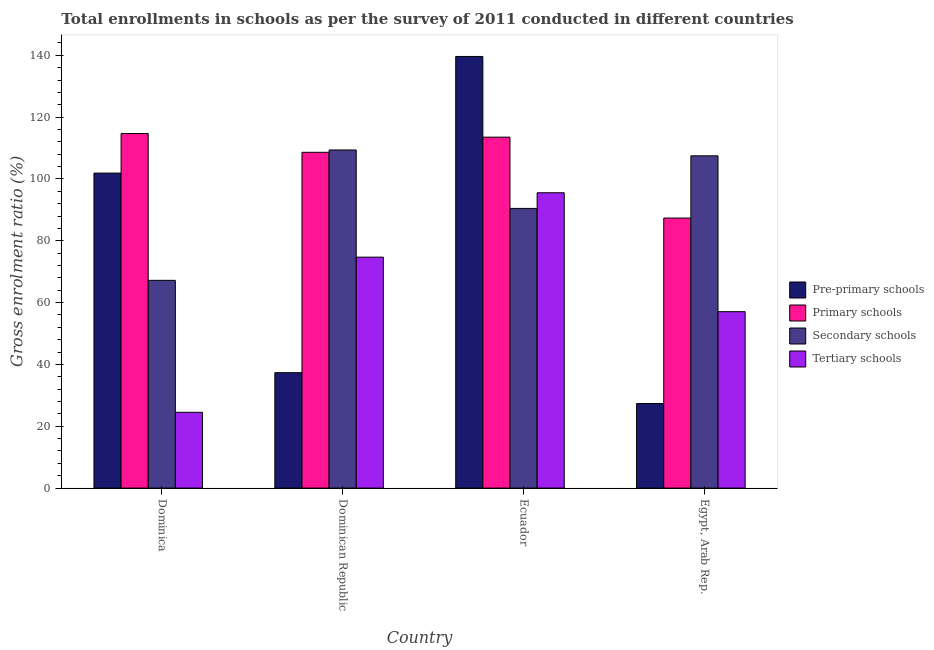How many different coloured bars are there?
Your response must be concise. 4. Are the number of bars on each tick of the X-axis equal?
Offer a terse response. Yes. How many bars are there on the 4th tick from the left?
Your response must be concise. 4. How many bars are there on the 1st tick from the right?
Make the answer very short. 4. What is the label of the 1st group of bars from the left?
Make the answer very short. Dominica. In how many cases, is the number of bars for a given country not equal to the number of legend labels?
Ensure brevity in your answer.  0. What is the gross enrolment ratio in pre-primary schools in Ecuador?
Offer a very short reply. 139.63. Across all countries, what is the maximum gross enrolment ratio in secondary schools?
Provide a short and direct response. 109.37. Across all countries, what is the minimum gross enrolment ratio in primary schools?
Keep it short and to the point. 87.36. In which country was the gross enrolment ratio in secondary schools maximum?
Give a very brief answer. Dominican Republic. In which country was the gross enrolment ratio in tertiary schools minimum?
Offer a terse response. Dominica. What is the total gross enrolment ratio in tertiary schools in the graph?
Your answer should be compact. 251.82. What is the difference between the gross enrolment ratio in tertiary schools in Dominica and that in Dominican Republic?
Your answer should be very brief. -50.19. What is the difference between the gross enrolment ratio in primary schools in Dominica and the gross enrolment ratio in secondary schools in Dominican Republic?
Provide a succinct answer. 5.33. What is the average gross enrolment ratio in pre-primary schools per country?
Offer a terse response. 76.56. What is the difference between the gross enrolment ratio in tertiary schools and gross enrolment ratio in primary schools in Egypt, Arab Rep.?
Provide a short and direct response. -30.29. What is the ratio of the gross enrolment ratio in pre-primary schools in Dominican Republic to that in Ecuador?
Ensure brevity in your answer.  0.27. Is the gross enrolment ratio in primary schools in Dominica less than that in Ecuador?
Your response must be concise. No. What is the difference between the highest and the second highest gross enrolment ratio in secondary schools?
Ensure brevity in your answer.  1.9. What is the difference between the highest and the lowest gross enrolment ratio in secondary schools?
Provide a short and direct response. 42.17. In how many countries, is the gross enrolment ratio in tertiary schools greater than the average gross enrolment ratio in tertiary schools taken over all countries?
Offer a terse response. 2. Is the sum of the gross enrolment ratio in tertiary schools in Dominican Republic and Egypt, Arab Rep. greater than the maximum gross enrolment ratio in pre-primary schools across all countries?
Offer a terse response. No. What does the 3rd bar from the left in Ecuador represents?
Give a very brief answer. Secondary schools. What does the 4th bar from the right in Dominican Republic represents?
Make the answer very short. Pre-primary schools. Are all the bars in the graph horizontal?
Provide a short and direct response. No. What is the difference between two consecutive major ticks on the Y-axis?
Your answer should be compact. 20. Does the graph contain grids?
Keep it short and to the point. No. Where does the legend appear in the graph?
Make the answer very short. Center right. What is the title of the graph?
Offer a very short reply. Total enrollments in schools as per the survey of 2011 conducted in different countries. What is the label or title of the X-axis?
Provide a succinct answer. Country. What is the Gross enrolment ratio (%) of Pre-primary schools in Dominica?
Your response must be concise. 101.9. What is the Gross enrolment ratio (%) of Primary schools in Dominica?
Offer a terse response. 114.7. What is the Gross enrolment ratio (%) in Secondary schools in Dominica?
Ensure brevity in your answer.  67.2. What is the Gross enrolment ratio (%) in Tertiary schools in Dominica?
Provide a short and direct response. 24.52. What is the Gross enrolment ratio (%) in Pre-primary schools in Dominican Republic?
Make the answer very short. 37.33. What is the Gross enrolment ratio (%) in Primary schools in Dominican Republic?
Provide a succinct answer. 108.62. What is the Gross enrolment ratio (%) of Secondary schools in Dominican Republic?
Your answer should be very brief. 109.37. What is the Gross enrolment ratio (%) of Tertiary schools in Dominican Republic?
Provide a succinct answer. 74.71. What is the Gross enrolment ratio (%) of Pre-primary schools in Ecuador?
Offer a terse response. 139.63. What is the Gross enrolment ratio (%) of Primary schools in Ecuador?
Make the answer very short. 113.53. What is the Gross enrolment ratio (%) of Secondary schools in Ecuador?
Your answer should be very brief. 90.47. What is the Gross enrolment ratio (%) of Tertiary schools in Ecuador?
Provide a short and direct response. 95.54. What is the Gross enrolment ratio (%) of Pre-primary schools in Egypt, Arab Rep.?
Your answer should be very brief. 27.36. What is the Gross enrolment ratio (%) of Primary schools in Egypt, Arab Rep.?
Make the answer very short. 87.36. What is the Gross enrolment ratio (%) in Secondary schools in Egypt, Arab Rep.?
Make the answer very short. 107.48. What is the Gross enrolment ratio (%) of Tertiary schools in Egypt, Arab Rep.?
Your response must be concise. 57.06. Across all countries, what is the maximum Gross enrolment ratio (%) in Pre-primary schools?
Offer a very short reply. 139.63. Across all countries, what is the maximum Gross enrolment ratio (%) of Primary schools?
Give a very brief answer. 114.7. Across all countries, what is the maximum Gross enrolment ratio (%) in Secondary schools?
Your answer should be very brief. 109.37. Across all countries, what is the maximum Gross enrolment ratio (%) of Tertiary schools?
Your response must be concise. 95.54. Across all countries, what is the minimum Gross enrolment ratio (%) in Pre-primary schools?
Keep it short and to the point. 27.36. Across all countries, what is the minimum Gross enrolment ratio (%) in Primary schools?
Ensure brevity in your answer.  87.36. Across all countries, what is the minimum Gross enrolment ratio (%) of Secondary schools?
Offer a very short reply. 67.2. Across all countries, what is the minimum Gross enrolment ratio (%) of Tertiary schools?
Make the answer very short. 24.52. What is the total Gross enrolment ratio (%) of Pre-primary schools in the graph?
Offer a terse response. 306.22. What is the total Gross enrolment ratio (%) in Primary schools in the graph?
Keep it short and to the point. 424.21. What is the total Gross enrolment ratio (%) of Secondary schools in the graph?
Ensure brevity in your answer.  374.53. What is the total Gross enrolment ratio (%) of Tertiary schools in the graph?
Offer a very short reply. 251.82. What is the difference between the Gross enrolment ratio (%) of Pre-primary schools in Dominica and that in Dominican Republic?
Ensure brevity in your answer.  64.57. What is the difference between the Gross enrolment ratio (%) of Primary schools in Dominica and that in Dominican Republic?
Your answer should be compact. 6.08. What is the difference between the Gross enrolment ratio (%) in Secondary schools in Dominica and that in Dominican Republic?
Offer a terse response. -42.17. What is the difference between the Gross enrolment ratio (%) in Tertiary schools in Dominica and that in Dominican Republic?
Ensure brevity in your answer.  -50.19. What is the difference between the Gross enrolment ratio (%) in Pre-primary schools in Dominica and that in Ecuador?
Keep it short and to the point. -37.73. What is the difference between the Gross enrolment ratio (%) of Primary schools in Dominica and that in Ecuador?
Keep it short and to the point. 1.18. What is the difference between the Gross enrolment ratio (%) in Secondary schools in Dominica and that in Ecuador?
Provide a succinct answer. -23.27. What is the difference between the Gross enrolment ratio (%) of Tertiary schools in Dominica and that in Ecuador?
Give a very brief answer. -71.02. What is the difference between the Gross enrolment ratio (%) of Pre-primary schools in Dominica and that in Egypt, Arab Rep.?
Give a very brief answer. 74.54. What is the difference between the Gross enrolment ratio (%) of Primary schools in Dominica and that in Egypt, Arab Rep.?
Give a very brief answer. 27.35. What is the difference between the Gross enrolment ratio (%) in Secondary schools in Dominica and that in Egypt, Arab Rep.?
Provide a short and direct response. -40.28. What is the difference between the Gross enrolment ratio (%) of Tertiary schools in Dominica and that in Egypt, Arab Rep.?
Provide a succinct answer. -32.55. What is the difference between the Gross enrolment ratio (%) in Pre-primary schools in Dominican Republic and that in Ecuador?
Your answer should be very brief. -102.29. What is the difference between the Gross enrolment ratio (%) in Primary schools in Dominican Republic and that in Ecuador?
Make the answer very short. -4.91. What is the difference between the Gross enrolment ratio (%) of Secondary schools in Dominican Republic and that in Ecuador?
Keep it short and to the point. 18.9. What is the difference between the Gross enrolment ratio (%) of Tertiary schools in Dominican Republic and that in Ecuador?
Provide a succinct answer. -20.83. What is the difference between the Gross enrolment ratio (%) in Pre-primary schools in Dominican Republic and that in Egypt, Arab Rep.?
Provide a short and direct response. 9.97. What is the difference between the Gross enrolment ratio (%) in Primary schools in Dominican Republic and that in Egypt, Arab Rep.?
Your response must be concise. 21.26. What is the difference between the Gross enrolment ratio (%) in Secondary schools in Dominican Republic and that in Egypt, Arab Rep.?
Your response must be concise. 1.9. What is the difference between the Gross enrolment ratio (%) of Tertiary schools in Dominican Republic and that in Egypt, Arab Rep.?
Keep it short and to the point. 17.64. What is the difference between the Gross enrolment ratio (%) in Pre-primary schools in Ecuador and that in Egypt, Arab Rep.?
Your answer should be compact. 112.26. What is the difference between the Gross enrolment ratio (%) in Primary schools in Ecuador and that in Egypt, Arab Rep.?
Give a very brief answer. 26.17. What is the difference between the Gross enrolment ratio (%) of Secondary schools in Ecuador and that in Egypt, Arab Rep.?
Your response must be concise. -17.01. What is the difference between the Gross enrolment ratio (%) in Tertiary schools in Ecuador and that in Egypt, Arab Rep.?
Make the answer very short. 38.47. What is the difference between the Gross enrolment ratio (%) of Pre-primary schools in Dominica and the Gross enrolment ratio (%) of Primary schools in Dominican Republic?
Your response must be concise. -6.72. What is the difference between the Gross enrolment ratio (%) of Pre-primary schools in Dominica and the Gross enrolment ratio (%) of Secondary schools in Dominican Republic?
Your answer should be compact. -7.47. What is the difference between the Gross enrolment ratio (%) of Pre-primary schools in Dominica and the Gross enrolment ratio (%) of Tertiary schools in Dominican Republic?
Offer a very short reply. 27.19. What is the difference between the Gross enrolment ratio (%) in Primary schools in Dominica and the Gross enrolment ratio (%) in Secondary schools in Dominican Republic?
Offer a terse response. 5.33. What is the difference between the Gross enrolment ratio (%) in Primary schools in Dominica and the Gross enrolment ratio (%) in Tertiary schools in Dominican Republic?
Keep it short and to the point. 40. What is the difference between the Gross enrolment ratio (%) in Secondary schools in Dominica and the Gross enrolment ratio (%) in Tertiary schools in Dominican Republic?
Your answer should be very brief. -7.5. What is the difference between the Gross enrolment ratio (%) in Pre-primary schools in Dominica and the Gross enrolment ratio (%) in Primary schools in Ecuador?
Provide a short and direct response. -11.63. What is the difference between the Gross enrolment ratio (%) of Pre-primary schools in Dominica and the Gross enrolment ratio (%) of Secondary schools in Ecuador?
Your answer should be compact. 11.43. What is the difference between the Gross enrolment ratio (%) in Pre-primary schools in Dominica and the Gross enrolment ratio (%) in Tertiary schools in Ecuador?
Offer a very short reply. 6.36. What is the difference between the Gross enrolment ratio (%) in Primary schools in Dominica and the Gross enrolment ratio (%) in Secondary schools in Ecuador?
Provide a succinct answer. 24.23. What is the difference between the Gross enrolment ratio (%) of Primary schools in Dominica and the Gross enrolment ratio (%) of Tertiary schools in Ecuador?
Keep it short and to the point. 19.17. What is the difference between the Gross enrolment ratio (%) in Secondary schools in Dominica and the Gross enrolment ratio (%) in Tertiary schools in Ecuador?
Ensure brevity in your answer.  -28.33. What is the difference between the Gross enrolment ratio (%) of Pre-primary schools in Dominica and the Gross enrolment ratio (%) of Primary schools in Egypt, Arab Rep.?
Ensure brevity in your answer.  14.54. What is the difference between the Gross enrolment ratio (%) of Pre-primary schools in Dominica and the Gross enrolment ratio (%) of Secondary schools in Egypt, Arab Rep.?
Offer a very short reply. -5.58. What is the difference between the Gross enrolment ratio (%) in Pre-primary schools in Dominica and the Gross enrolment ratio (%) in Tertiary schools in Egypt, Arab Rep.?
Your response must be concise. 44.84. What is the difference between the Gross enrolment ratio (%) of Primary schools in Dominica and the Gross enrolment ratio (%) of Secondary schools in Egypt, Arab Rep.?
Keep it short and to the point. 7.23. What is the difference between the Gross enrolment ratio (%) in Primary schools in Dominica and the Gross enrolment ratio (%) in Tertiary schools in Egypt, Arab Rep.?
Your answer should be very brief. 57.64. What is the difference between the Gross enrolment ratio (%) in Secondary schools in Dominica and the Gross enrolment ratio (%) in Tertiary schools in Egypt, Arab Rep.?
Your answer should be compact. 10.14. What is the difference between the Gross enrolment ratio (%) in Pre-primary schools in Dominican Republic and the Gross enrolment ratio (%) in Primary schools in Ecuador?
Provide a short and direct response. -76.19. What is the difference between the Gross enrolment ratio (%) of Pre-primary schools in Dominican Republic and the Gross enrolment ratio (%) of Secondary schools in Ecuador?
Keep it short and to the point. -53.14. What is the difference between the Gross enrolment ratio (%) in Pre-primary schools in Dominican Republic and the Gross enrolment ratio (%) in Tertiary schools in Ecuador?
Make the answer very short. -58.2. What is the difference between the Gross enrolment ratio (%) in Primary schools in Dominican Republic and the Gross enrolment ratio (%) in Secondary schools in Ecuador?
Provide a succinct answer. 18.15. What is the difference between the Gross enrolment ratio (%) of Primary schools in Dominican Republic and the Gross enrolment ratio (%) of Tertiary schools in Ecuador?
Your response must be concise. 13.08. What is the difference between the Gross enrolment ratio (%) in Secondary schools in Dominican Republic and the Gross enrolment ratio (%) in Tertiary schools in Ecuador?
Offer a very short reply. 13.84. What is the difference between the Gross enrolment ratio (%) of Pre-primary schools in Dominican Republic and the Gross enrolment ratio (%) of Primary schools in Egypt, Arab Rep.?
Make the answer very short. -50.03. What is the difference between the Gross enrolment ratio (%) of Pre-primary schools in Dominican Republic and the Gross enrolment ratio (%) of Secondary schools in Egypt, Arab Rep.?
Give a very brief answer. -70.15. What is the difference between the Gross enrolment ratio (%) in Pre-primary schools in Dominican Republic and the Gross enrolment ratio (%) in Tertiary schools in Egypt, Arab Rep.?
Your response must be concise. -19.73. What is the difference between the Gross enrolment ratio (%) in Primary schools in Dominican Republic and the Gross enrolment ratio (%) in Secondary schools in Egypt, Arab Rep.?
Your response must be concise. 1.14. What is the difference between the Gross enrolment ratio (%) of Primary schools in Dominican Republic and the Gross enrolment ratio (%) of Tertiary schools in Egypt, Arab Rep.?
Your response must be concise. 51.56. What is the difference between the Gross enrolment ratio (%) in Secondary schools in Dominican Republic and the Gross enrolment ratio (%) in Tertiary schools in Egypt, Arab Rep.?
Make the answer very short. 52.31. What is the difference between the Gross enrolment ratio (%) in Pre-primary schools in Ecuador and the Gross enrolment ratio (%) in Primary schools in Egypt, Arab Rep.?
Give a very brief answer. 52.27. What is the difference between the Gross enrolment ratio (%) in Pre-primary schools in Ecuador and the Gross enrolment ratio (%) in Secondary schools in Egypt, Arab Rep.?
Keep it short and to the point. 32.15. What is the difference between the Gross enrolment ratio (%) in Pre-primary schools in Ecuador and the Gross enrolment ratio (%) in Tertiary schools in Egypt, Arab Rep.?
Keep it short and to the point. 82.56. What is the difference between the Gross enrolment ratio (%) in Primary schools in Ecuador and the Gross enrolment ratio (%) in Secondary schools in Egypt, Arab Rep.?
Ensure brevity in your answer.  6.05. What is the difference between the Gross enrolment ratio (%) in Primary schools in Ecuador and the Gross enrolment ratio (%) in Tertiary schools in Egypt, Arab Rep.?
Your response must be concise. 56.46. What is the difference between the Gross enrolment ratio (%) in Secondary schools in Ecuador and the Gross enrolment ratio (%) in Tertiary schools in Egypt, Arab Rep.?
Keep it short and to the point. 33.41. What is the average Gross enrolment ratio (%) in Pre-primary schools per country?
Your answer should be very brief. 76.56. What is the average Gross enrolment ratio (%) of Primary schools per country?
Make the answer very short. 106.05. What is the average Gross enrolment ratio (%) in Secondary schools per country?
Ensure brevity in your answer.  93.63. What is the average Gross enrolment ratio (%) of Tertiary schools per country?
Your answer should be compact. 62.96. What is the difference between the Gross enrolment ratio (%) in Pre-primary schools and Gross enrolment ratio (%) in Primary schools in Dominica?
Keep it short and to the point. -12.8. What is the difference between the Gross enrolment ratio (%) of Pre-primary schools and Gross enrolment ratio (%) of Secondary schools in Dominica?
Your response must be concise. 34.7. What is the difference between the Gross enrolment ratio (%) of Pre-primary schools and Gross enrolment ratio (%) of Tertiary schools in Dominica?
Offer a very short reply. 77.38. What is the difference between the Gross enrolment ratio (%) of Primary schools and Gross enrolment ratio (%) of Secondary schools in Dominica?
Offer a terse response. 47.5. What is the difference between the Gross enrolment ratio (%) in Primary schools and Gross enrolment ratio (%) in Tertiary schools in Dominica?
Your answer should be very brief. 90.19. What is the difference between the Gross enrolment ratio (%) of Secondary schools and Gross enrolment ratio (%) of Tertiary schools in Dominica?
Keep it short and to the point. 42.68. What is the difference between the Gross enrolment ratio (%) of Pre-primary schools and Gross enrolment ratio (%) of Primary schools in Dominican Republic?
Keep it short and to the point. -71.29. What is the difference between the Gross enrolment ratio (%) of Pre-primary schools and Gross enrolment ratio (%) of Secondary schools in Dominican Republic?
Make the answer very short. -72.04. What is the difference between the Gross enrolment ratio (%) of Pre-primary schools and Gross enrolment ratio (%) of Tertiary schools in Dominican Republic?
Offer a terse response. -37.37. What is the difference between the Gross enrolment ratio (%) of Primary schools and Gross enrolment ratio (%) of Secondary schools in Dominican Republic?
Your answer should be very brief. -0.75. What is the difference between the Gross enrolment ratio (%) in Primary schools and Gross enrolment ratio (%) in Tertiary schools in Dominican Republic?
Provide a succinct answer. 33.92. What is the difference between the Gross enrolment ratio (%) of Secondary schools and Gross enrolment ratio (%) of Tertiary schools in Dominican Republic?
Offer a very short reply. 34.67. What is the difference between the Gross enrolment ratio (%) of Pre-primary schools and Gross enrolment ratio (%) of Primary schools in Ecuador?
Offer a very short reply. 26.1. What is the difference between the Gross enrolment ratio (%) of Pre-primary schools and Gross enrolment ratio (%) of Secondary schools in Ecuador?
Your answer should be compact. 49.15. What is the difference between the Gross enrolment ratio (%) in Pre-primary schools and Gross enrolment ratio (%) in Tertiary schools in Ecuador?
Offer a terse response. 44.09. What is the difference between the Gross enrolment ratio (%) of Primary schools and Gross enrolment ratio (%) of Secondary schools in Ecuador?
Your answer should be compact. 23.05. What is the difference between the Gross enrolment ratio (%) of Primary schools and Gross enrolment ratio (%) of Tertiary schools in Ecuador?
Your response must be concise. 17.99. What is the difference between the Gross enrolment ratio (%) of Secondary schools and Gross enrolment ratio (%) of Tertiary schools in Ecuador?
Your response must be concise. -5.07. What is the difference between the Gross enrolment ratio (%) of Pre-primary schools and Gross enrolment ratio (%) of Primary schools in Egypt, Arab Rep.?
Keep it short and to the point. -59.99. What is the difference between the Gross enrolment ratio (%) of Pre-primary schools and Gross enrolment ratio (%) of Secondary schools in Egypt, Arab Rep.?
Keep it short and to the point. -80.12. What is the difference between the Gross enrolment ratio (%) of Pre-primary schools and Gross enrolment ratio (%) of Tertiary schools in Egypt, Arab Rep.?
Offer a terse response. -29.7. What is the difference between the Gross enrolment ratio (%) in Primary schools and Gross enrolment ratio (%) in Secondary schools in Egypt, Arab Rep.?
Provide a succinct answer. -20.12. What is the difference between the Gross enrolment ratio (%) in Primary schools and Gross enrolment ratio (%) in Tertiary schools in Egypt, Arab Rep.?
Provide a succinct answer. 30.29. What is the difference between the Gross enrolment ratio (%) of Secondary schools and Gross enrolment ratio (%) of Tertiary schools in Egypt, Arab Rep.?
Ensure brevity in your answer.  50.41. What is the ratio of the Gross enrolment ratio (%) of Pre-primary schools in Dominica to that in Dominican Republic?
Provide a short and direct response. 2.73. What is the ratio of the Gross enrolment ratio (%) in Primary schools in Dominica to that in Dominican Republic?
Make the answer very short. 1.06. What is the ratio of the Gross enrolment ratio (%) of Secondary schools in Dominica to that in Dominican Republic?
Ensure brevity in your answer.  0.61. What is the ratio of the Gross enrolment ratio (%) of Tertiary schools in Dominica to that in Dominican Republic?
Your answer should be compact. 0.33. What is the ratio of the Gross enrolment ratio (%) of Pre-primary schools in Dominica to that in Ecuador?
Offer a very short reply. 0.73. What is the ratio of the Gross enrolment ratio (%) in Primary schools in Dominica to that in Ecuador?
Provide a succinct answer. 1.01. What is the ratio of the Gross enrolment ratio (%) in Secondary schools in Dominica to that in Ecuador?
Ensure brevity in your answer.  0.74. What is the ratio of the Gross enrolment ratio (%) in Tertiary schools in Dominica to that in Ecuador?
Make the answer very short. 0.26. What is the ratio of the Gross enrolment ratio (%) of Pre-primary schools in Dominica to that in Egypt, Arab Rep.?
Your answer should be compact. 3.72. What is the ratio of the Gross enrolment ratio (%) in Primary schools in Dominica to that in Egypt, Arab Rep.?
Provide a succinct answer. 1.31. What is the ratio of the Gross enrolment ratio (%) in Secondary schools in Dominica to that in Egypt, Arab Rep.?
Your response must be concise. 0.63. What is the ratio of the Gross enrolment ratio (%) of Tertiary schools in Dominica to that in Egypt, Arab Rep.?
Your answer should be compact. 0.43. What is the ratio of the Gross enrolment ratio (%) of Pre-primary schools in Dominican Republic to that in Ecuador?
Ensure brevity in your answer.  0.27. What is the ratio of the Gross enrolment ratio (%) in Primary schools in Dominican Republic to that in Ecuador?
Keep it short and to the point. 0.96. What is the ratio of the Gross enrolment ratio (%) in Secondary schools in Dominican Republic to that in Ecuador?
Provide a short and direct response. 1.21. What is the ratio of the Gross enrolment ratio (%) of Tertiary schools in Dominican Republic to that in Ecuador?
Offer a very short reply. 0.78. What is the ratio of the Gross enrolment ratio (%) in Pre-primary schools in Dominican Republic to that in Egypt, Arab Rep.?
Make the answer very short. 1.36. What is the ratio of the Gross enrolment ratio (%) of Primary schools in Dominican Republic to that in Egypt, Arab Rep.?
Offer a terse response. 1.24. What is the ratio of the Gross enrolment ratio (%) of Secondary schools in Dominican Republic to that in Egypt, Arab Rep.?
Make the answer very short. 1.02. What is the ratio of the Gross enrolment ratio (%) of Tertiary schools in Dominican Republic to that in Egypt, Arab Rep.?
Provide a succinct answer. 1.31. What is the ratio of the Gross enrolment ratio (%) of Pre-primary schools in Ecuador to that in Egypt, Arab Rep.?
Make the answer very short. 5.1. What is the ratio of the Gross enrolment ratio (%) in Primary schools in Ecuador to that in Egypt, Arab Rep.?
Ensure brevity in your answer.  1.3. What is the ratio of the Gross enrolment ratio (%) in Secondary schools in Ecuador to that in Egypt, Arab Rep.?
Provide a succinct answer. 0.84. What is the ratio of the Gross enrolment ratio (%) of Tertiary schools in Ecuador to that in Egypt, Arab Rep.?
Provide a succinct answer. 1.67. What is the difference between the highest and the second highest Gross enrolment ratio (%) of Pre-primary schools?
Provide a short and direct response. 37.73. What is the difference between the highest and the second highest Gross enrolment ratio (%) in Primary schools?
Keep it short and to the point. 1.18. What is the difference between the highest and the second highest Gross enrolment ratio (%) of Secondary schools?
Your answer should be very brief. 1.9. What is the difference between the highest and the second highest Gross enrolment ratio (%) in Tertiary schools?
Ensure brevity in your answer.  20.83. What is the difference between the highest and the lowest Gross enrolment ratio (%) of Pre-primary schools?
Give a very brief answer. 112.26. What is the difference between the highest and the lowest Gross enrolment ratio (%) in Primary schools?
Provide a succinct answer. 27.35. What is the difference between the highest and the lowest Gross enrolment ratio (%) of Secondary schools?
Make the answer very short. 42.17. What is the difference between the highest and the lowest Gross enrolment ratio (%) of Tertiary schools?
Your response must be concise. 71.02. 